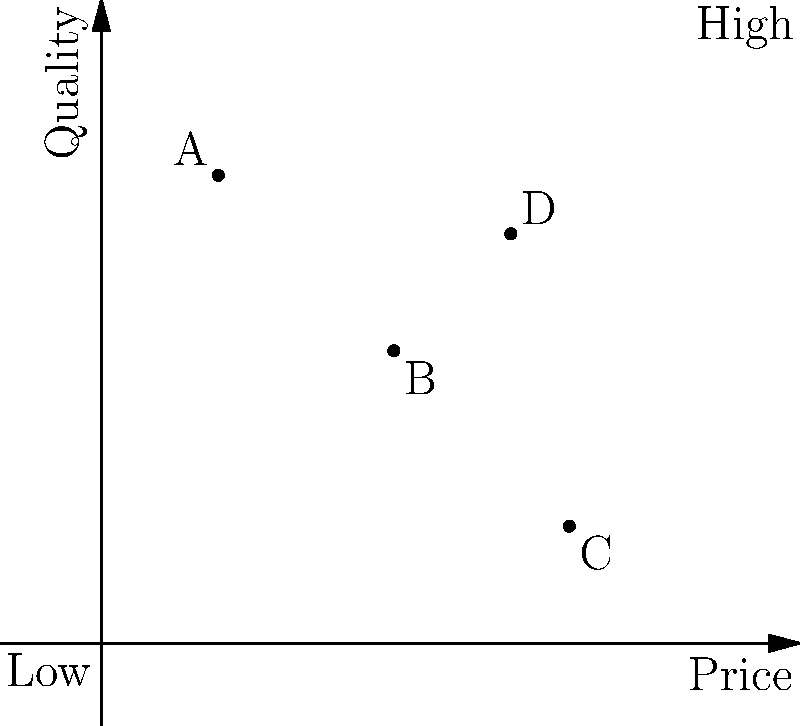In the context of a new product launch, analyze the perceptual map above showing the competitive positioning of four products (A, B, C, and D) based on price and quality. Which product would you recommend targeting for market share gain, and what strategy would you propose to achieve this? To answer this question, let's analyze the perceptual map step-by-step:

1. Interpret the axes:
   - X-axis: Price (left to right: low to high)
   - Y-axis: Quality (bottom to top: low to high)

2. Analyze each product's position:
   - Product A: Low price, high quality
   - Product B: Medium price, medium quality
   - Product C: High price, low quality
   - Product D: High price, high quality

3. Identify the most vulnerable competitor:
   Product C appears to be the most vulnerable, as it has a high price but low quality, which is generally an unfavorable position.

4. Develop a strategy:
   To gain market share from Product C, we should position our new product as offering better value. This can be achieved by:
   a) Offering higher quality at a similar price point
   b) Offering similar quality at a lower price point
   c) Ideally, a combination of both - slightly higher quality at a slightly lower price

5. Positioning the new product:
   Place the new product between B and D on the map, aiming for a position like (0.6, 0.6). This would offer better quality than C at a lower price.

6. Marketing strategy:
   Emphasize the value proposition in marketing communications, highlighting the superior quality-to-price ratio compared to Product C.

7. Launch approach:
   As a keynote speaker for innovative product launches, focus on the unique value proposition and how it addresses a gap in the current market, specifically targeting customers who may be dissatisfied with Product C's offering.
Answer: Target Product C; position new product between B and D, offering better quality at a lower price than C. 